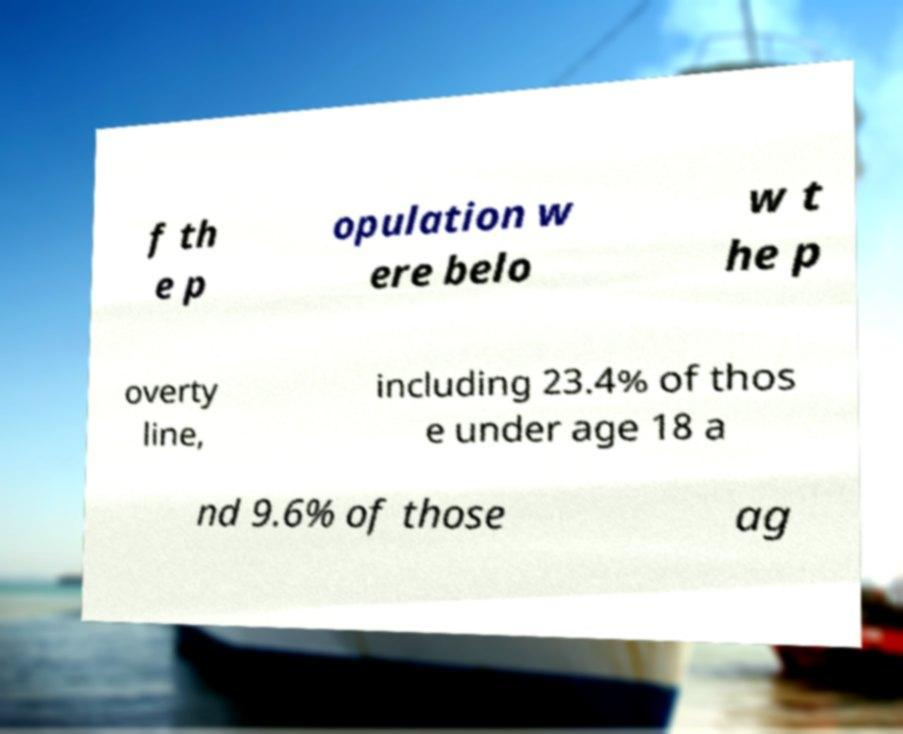What messages or text are displayed in this image? I need them in a readable, typed format. f th e p opulation w ere belo w t he p overty line, including 23.4% of thos e under age 18 a nd 9.6% of those ag 